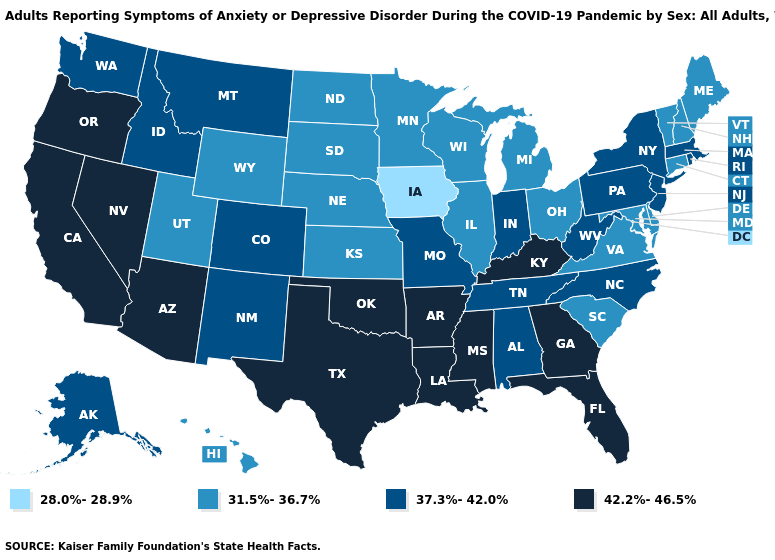What is the highest value in the West ?
Be succinct. 42.2%-46.5%. Name the states that have a value in the range 37.3%-42.0%?
Write a very short answer. Alabama, Alaska, Colorado, Idaho, Indiana, Massachusetts, Missouri, Montana, New Jersey, New Mexico, New York, North Carolina, Pennsylvania, Rhode Island, Tennessee, Washington, West Virginia. Does the first symbol in the legend represent the smallest category?
Write a very short answer. Yes. Does the map have missing data?
Give a very brief answer. No. Which states have the highest value in the USA?
Answer briefly. Arizona, Arkansas, California, Florida, Georgia, Kentucky, Louisiana, Mississippi, Nevada, Oklahoma, Oregon, Texas. Among the states that border Wisconsin , does Iowa have the highest value?
Concise answer only. No. What is the lowest value in the USA?
Quick response, please. 28.0%-28.9%. Name the states that have a value in the range 28.0%-28.9%?
Quick response, please. Iowa. Which states have the lowest value in the USA?
Be succinct. Iowa. What is the highest value in the USA?
Give a very brief answer. 42.2%-46.5%. What is the lowest value in the West?
Concise answer only. 31.5%-36.7%. What is the value of Maryland?
Be succinct. 31.5%-36.7%. Name the states that have a value in the range 42.2%-46.5%?
Give a very brief answer. Arizona, Arkansas, California, Florida, Georgia, Kentucky, Louisiana, Mississippi, Nevada, Oklahoma, Oregon, Texas. Is the legend a continuous bar?
Give a very brief answer. No. What is the value of Virginia?
Short answer required. 31.5%-36.7%. 